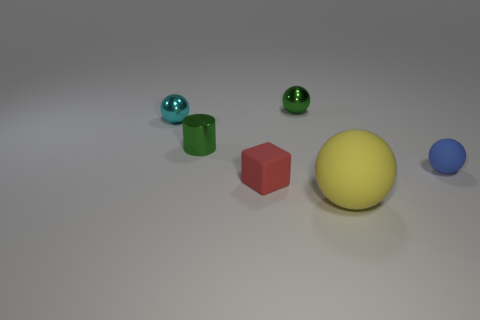Is there anything else that has the same size as the yellow rubber object?
Make the answer very short. No. The ball that is behind the tiny metal sphere that is left of the tiny metallic object on the right side of the cube is made of what material?
Your answer should be very brief. Metal. How many other objects are the same color as the cylinder?
Offer a terse response. 1. What number of green things are either blocks or rubber cylinders?
Provide a succinct answer. 0. What material is the small green ball behind the blue ball?
Your answer should be very brief. Metal. Do the tiny green object behind the small cyan sphere and the small cylinder have the same material?
Keep it short and to the point. Yes. The tiny red rubber object has what shape?
Provide a succinct answer. Cube. There is a tiny green object that is in front of the green shiny thing that is behind the tiny cyan object; how many tiny green metallic things are behind it?
Your response must be concise. 1. What number of other things are there of the same material as the tiny cylinder
Your answer should be very brief. 2. There is a green ball that is the same size as the cyan metal ball; what is it made of?
Your answer should be compact. Metal. 